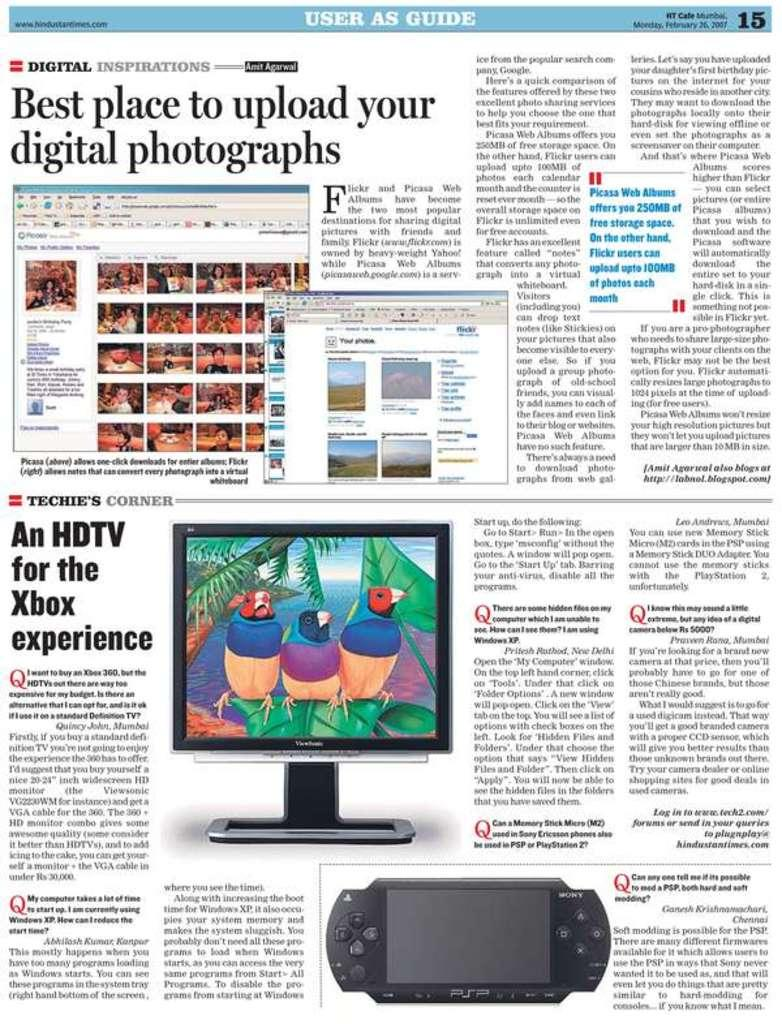<image>
Give a short and clear explanation of the subsequent image. The User as Guide reference give technical and digital tips to readers. 